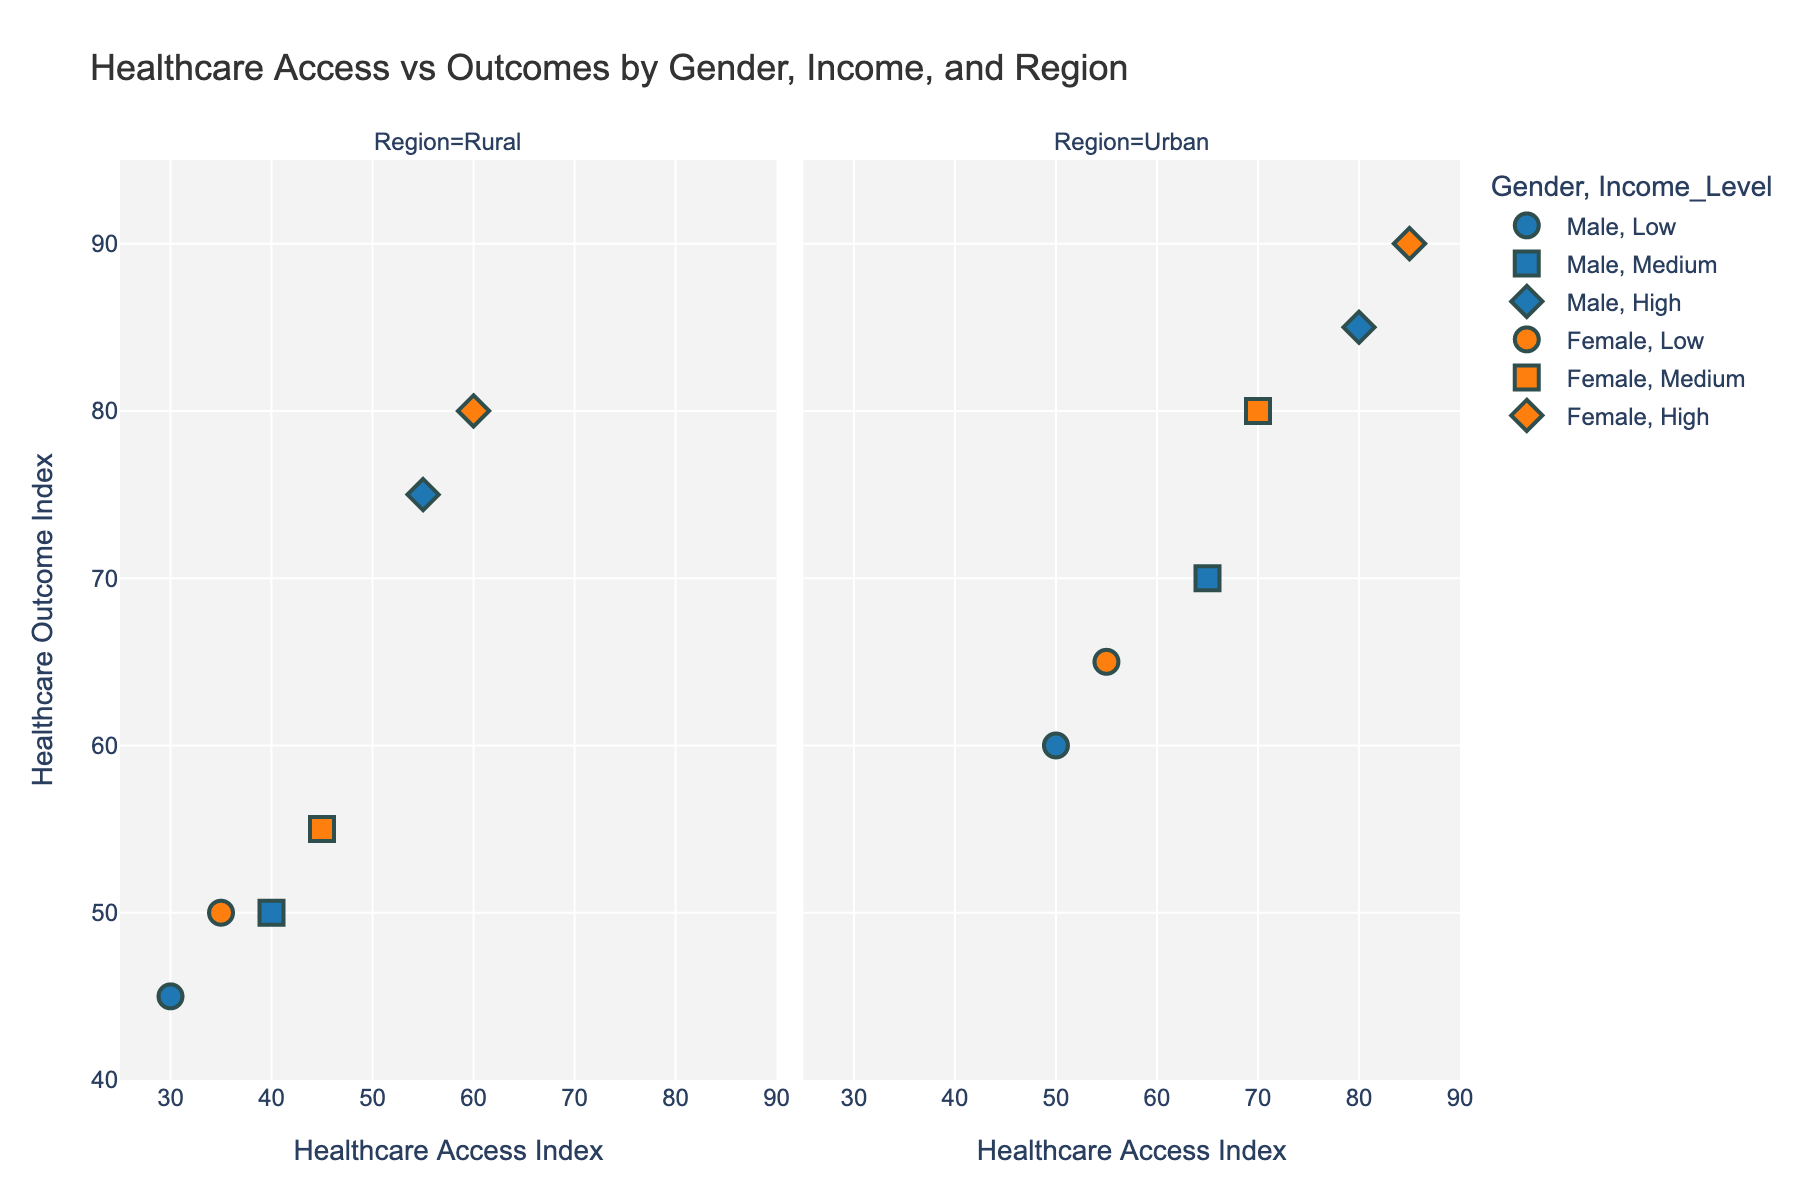What are the two regions displayed in this figure? The figure separates data points into two regions using facets, which are labeled at the top of each section of the plot. This means the visual representation is split into "Rural" and "Urban" areas.
Answer: Rural and Urban What is the range of the Healthcare Access Index on the x-axis? The x-axis of the plot, which represents the Healthcare Access Index, has a range starting at 25 and ending at 90, as shown by the axis labels and ticks.
Answer: 25 to 90 For the male grouped data points, does the High income level in Urban areas have a higher Healthcare Outcome Index than the High income level in Rural areas? In the Urban area facet, the male High income level data point is located at an Outcome Index of 85. In the Rural facet, the corresponding data point is at an Outcome Index of 75. By comparing these values, we see the Urban area has a higher index.
Answer: Yes What color represents female data points in the figure? The legend of the plot indicates that the color representing female data points is an orange hue. This is consistent across both the Rural and Urban facets.
Answer: Orange Which income level symbol is used for Medium income levels, and does this symbol appear more frequently in Urban or Rural regions? According to the legend, Medium income levels are represented by squares. By counting these square markers in the figure, we observe there are more squares in the Urban region compared to the Rural region.
Answer: Urban What's the difference in Healthcare Outcome Index between Female and Male individuals with Low income levels in Rural areas? In the Rural facet, the Female Low income level data point has an Outcome Index of 50, while the Male Low income level data point has an Outcome Index of 45. Subtracting the Male index from the Female index gives us 50 - 45 = 5.
Answer: 5 Which gender and income level combination exhibits the highest Healthcare Outcome Index in Urban areas? By scanning the Urban area facet, we identify that the highest Outcome Index is 90, which corresponds to Female individuals with High income levels. This is identified through the orange diamond symbol placed at the highest point on the y-axis.
Answer: Female, High income Is there any gender-income grouping in Rural areas where the Healthcare Access Index is above 50? Looking at the Rural area facet, we observe that the only data points with an Access Index above 50 are the Male and Female High income groups, each having values of 55 and 60 respectively.
Answer: Yes What's the average Healthcare Outcome Index for Female individuals in Urban areas across all income levels? Female individuals in Urban areas have Outcome Index values of 65, 80, and 90 for Low, Medium, and High incomes, respectively. Summing these values gives 65 + 80 + 90 = 235, and the average is 235 / 3 = 78.33.
Answer: 78.33 